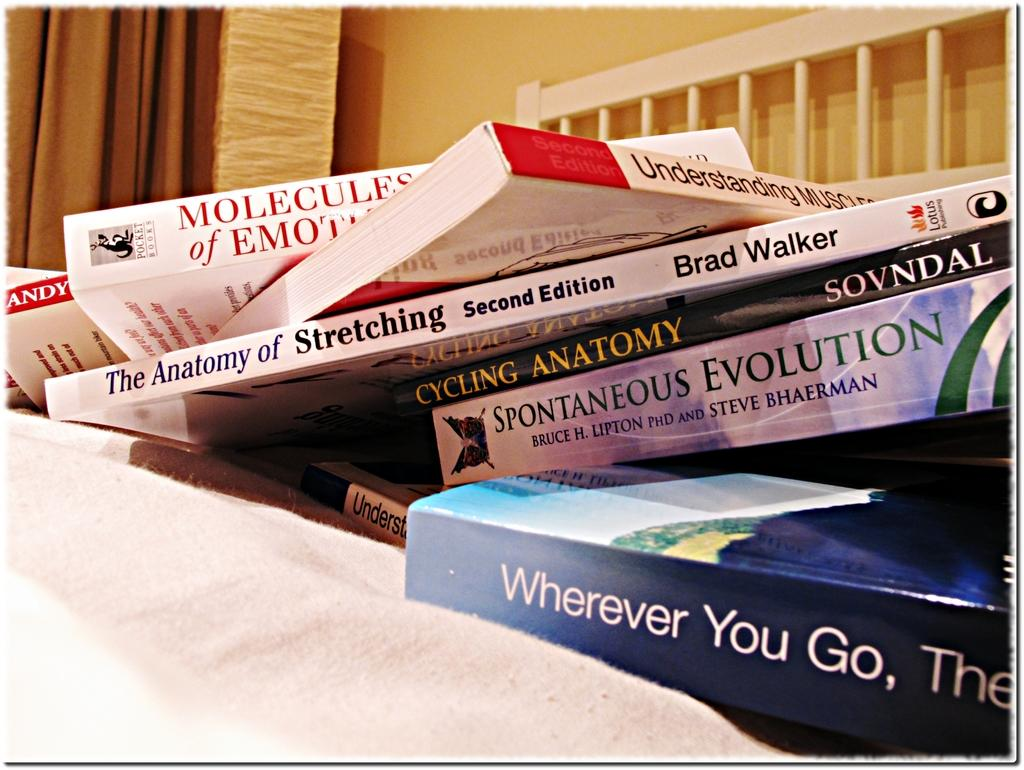<image>
Give a short and clear explanation of the subsequent image. Books including one titled Spontaneous Evolution are stacked on a pile. 